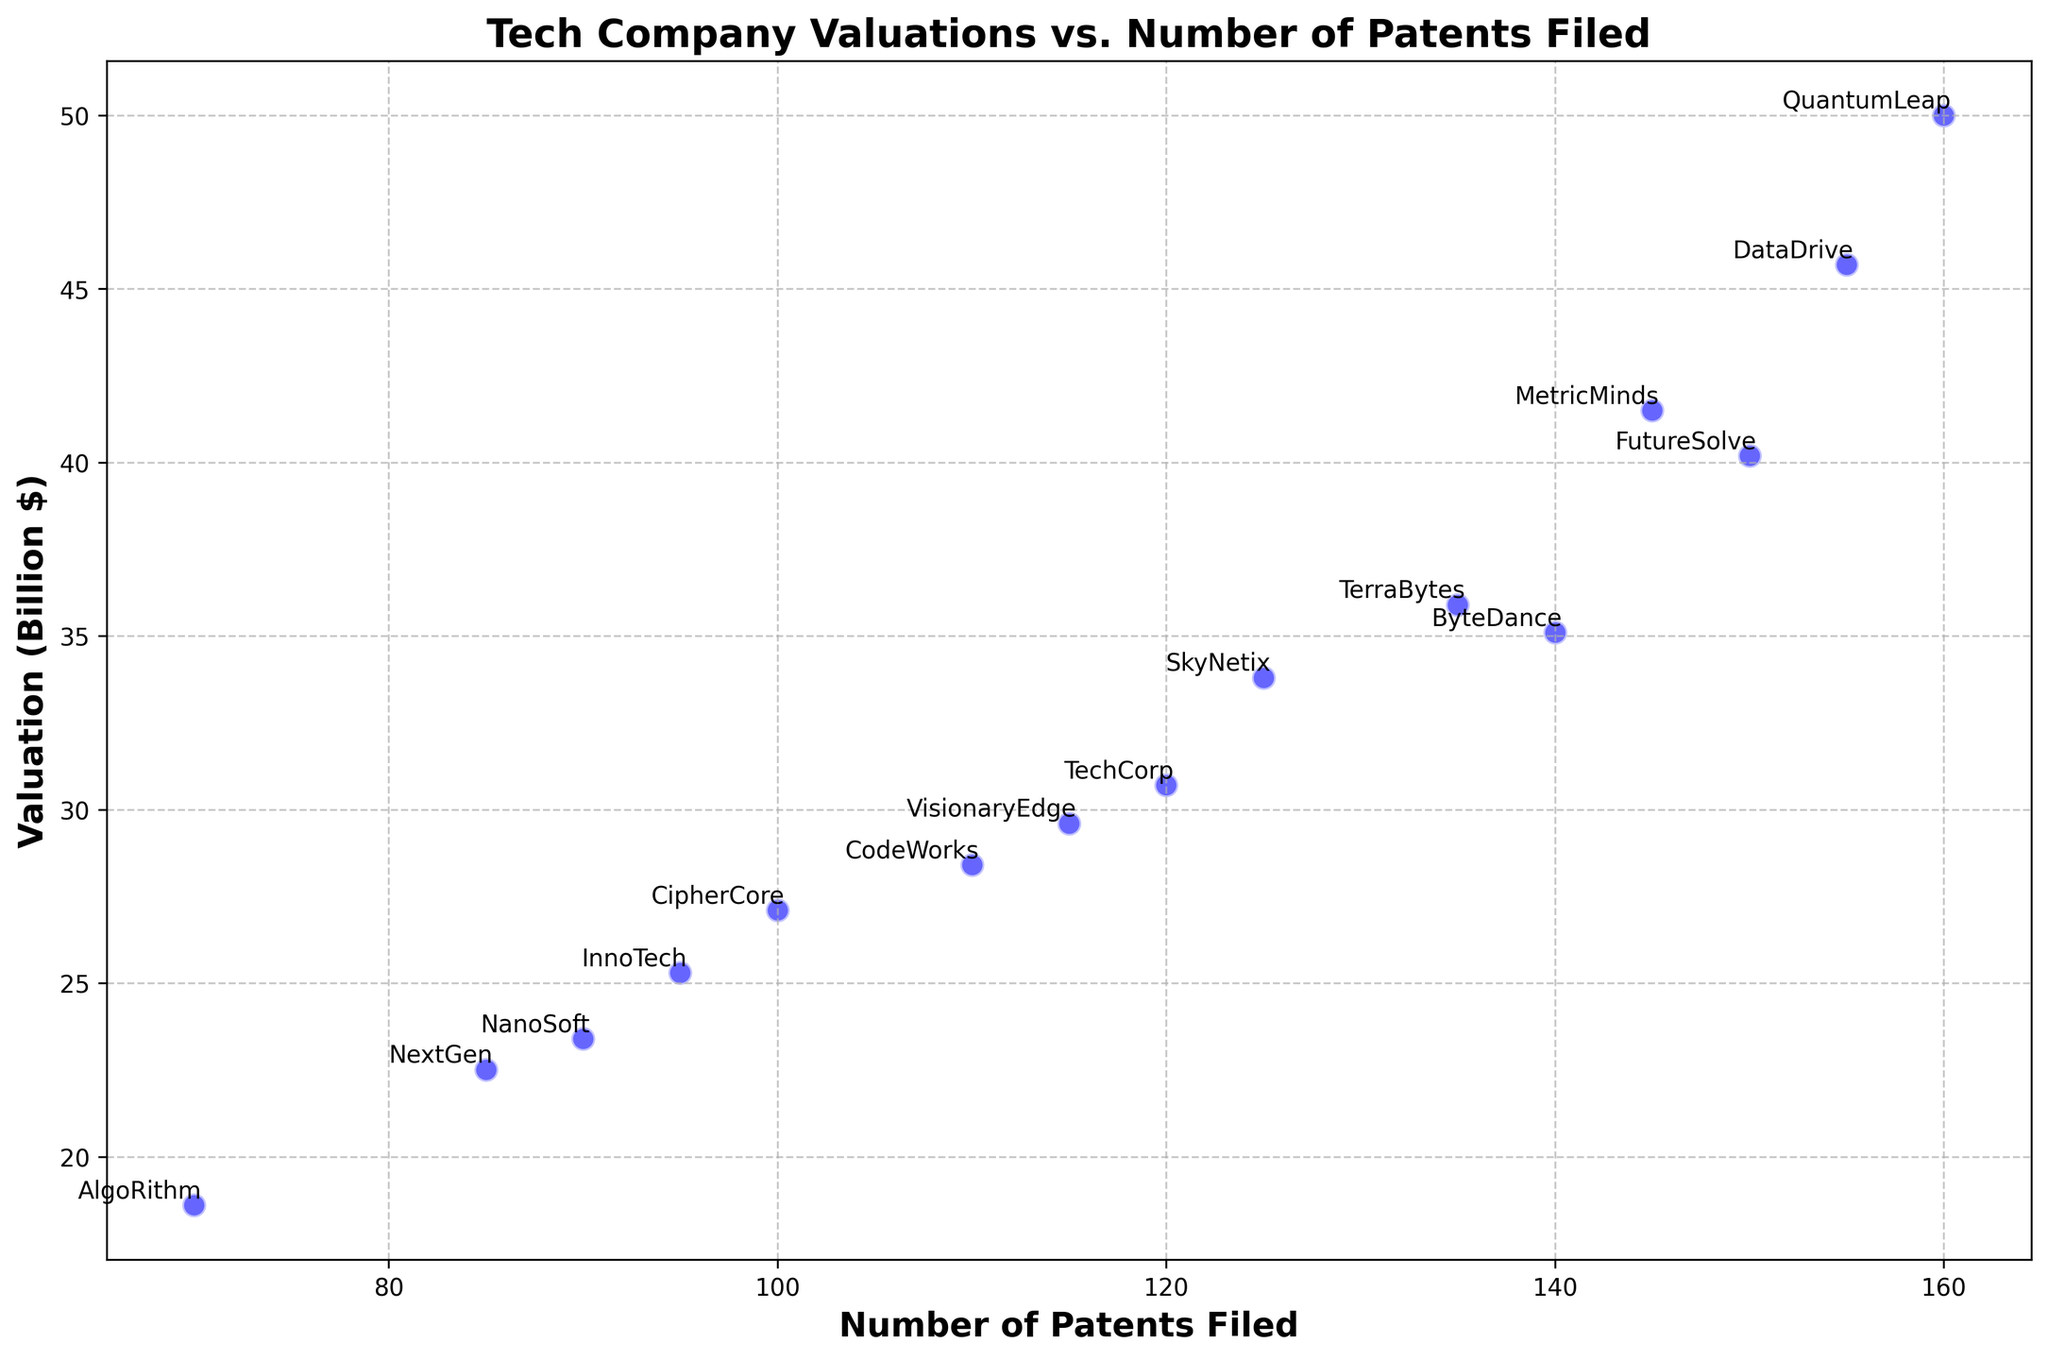Which company has the highest valuation? Check the company with the highest y-coordinate (valuation in billions). QuantumLeap has the highest valuation.
Answer: QuantumLeap Which company filed the lowest number of patents? Check the company with the lowest x-coordinate (patents filed). AlgoRithm has the lowest number of patents filed.
Answer: AlgoRithm What is the difference in valuation between DataDrive and SkyNetix? Locate both companies on the y-axis and subtract SkyNetix's valuation from DataDrive's. DataDrive's valuation is 45.7 billion, and SkyNetix's is 33.8 billion. The difference is 45.7 - 33.8.
Answer: 11.9 billion What is the average valuation of TechCorp and FutureSolve? Locate both companies on the y-axis. TechCorp's valuation is 30.7 billion, and FutureSolve's is 40.2 billion. The average is (30.7 + 40.2) / 2.
Answer: 35.45 billion Which company has more patents filed: InnoTech or CodeWorks? Locate both companies on the x-axis. InnoTech has 95 patents filed, and CodeWorks has 110 patents filed. CodeWorks has more patents filed.
Answer: CodeWorks What is the total number of patents filed by ByteDance and TerraBytes? Locate both companies on the x-axis. ByteDance has 140 patents filed, and TerraBytes has 135 patents filed. The total number is 140 + 135.
Answer: 275 Do QuantumLeap and DataDrive have the same number of patents filed? Locate both companies on the x-axis. QuantumLeap has 160 patents filed, and DataDrive has 155 patents filed. They do not have the same number.
Answer: No How many companies have a valuation greater than 30 billion dollars? Count the number of companies with y-coordinates (valuation) greater than 30. There are 8 companies: TechCorp, FutureSolve, ByteDance, QuantumLeap, DataDrive, SkyNetix, MetricMinds, TerraBytes.
Answer: 8 Which company has the closest valuation to VisionaryEdge? Locate VisionaryEdge on the y-axis and find the company with a valuation closest in value. VisionaryEdge has a valuation of 29.6 billion, and TechCorp has the closest valuation at 30.7 billion.
Answer: TechCorp 